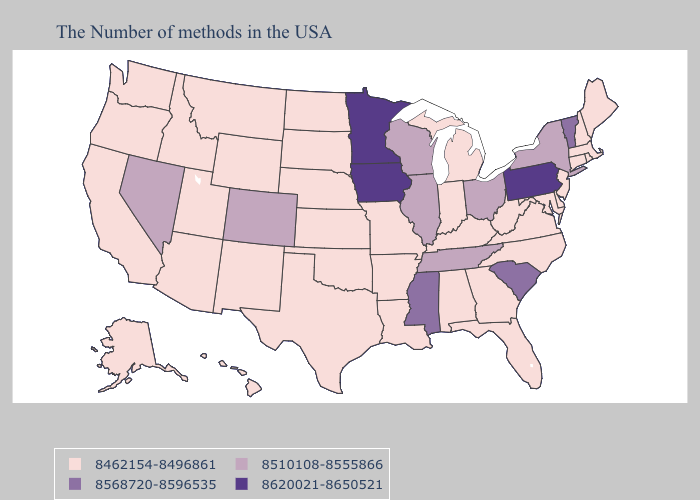Name the states that have a value in the range 8510108-8555866?
Write a very short answer. New York, Ohio, Tennessee, Wisconsin, Illinois, Colorado, Nevada. Does New Hampshire have the highest value in the Northeast?
Quick response, please. No. What is the highest value in the USA?
Concise answer only. 8620021-8650521. What is the value of California?
Keep it brief. 8462154-8496861. Name the states that have a value in the range 8620021-8650521?
Be succinct. Pennsylvania, Minnesota, Iowa. Does Rhode Island have a higher value than Minnesota?
Give a very brief answer. No. Among the states that border Utah , does Arizona have the highest value?
Give a very brief answer. No. What is the value of Michigan?
Concise answer only. 8462154-8496861. What is the value of New Hampshire?
Write a very short answer. 8462154-8496861. What is the value of Virginia?
Be succinct. 8462154-8496861. Is the legend a continuous bar?
Short answer required. No. What is the value of Tennessee?
Answer briefly. 8510108-8555866. What is the value of California?
Write a very short answer. 8462154-8496861. What is the value of Florida?
Answer briefly. 8462154-8496861. Name the states that have a value in the range 8462154-8496861?
Be succinct. Maine, Massachusetts, Rhode Island, New Hampshire, Connecticut, New Jersey, Delaware, Maryland, Virginia, North Carolina, West Virginia, Florida, Georgia, Michigan, Kentucky, Indiana, Alabama, Louisiana, Missouri, Arkansas, Kansas, Nebraska, Oklahoma, Texas, South Dakota, North Dakota, Wyoming, New Mexico, Utah, Montana, Arizona, Idaho, California, Washington, Oregon, Alaska, Hawaii. 